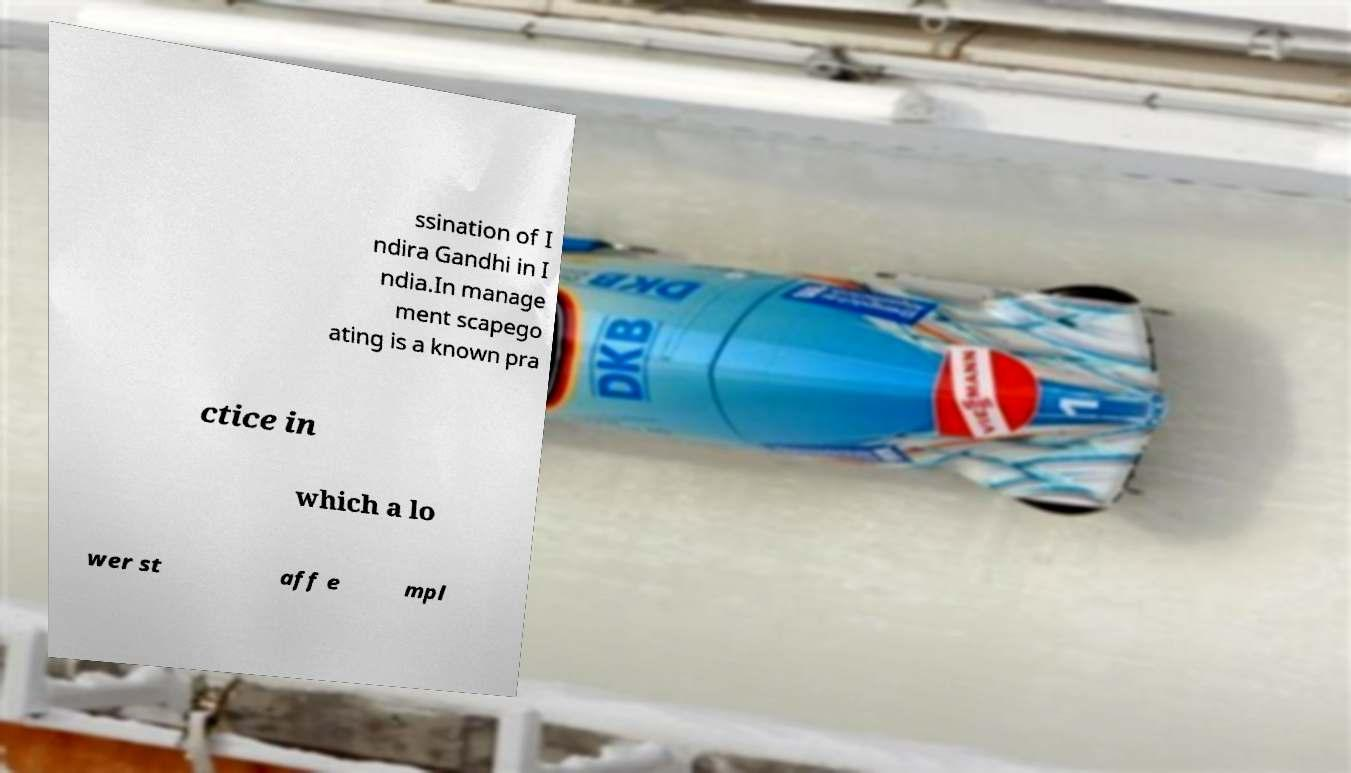Can you read and provide the text displayed in the image?This photo seems to have some interesting text. Can you extract and type it out for me? ssination of I ndira Gandhi in I ndia.In manage ment scapego ating is a known pra ctice in which a lo wer st aff e mpl 